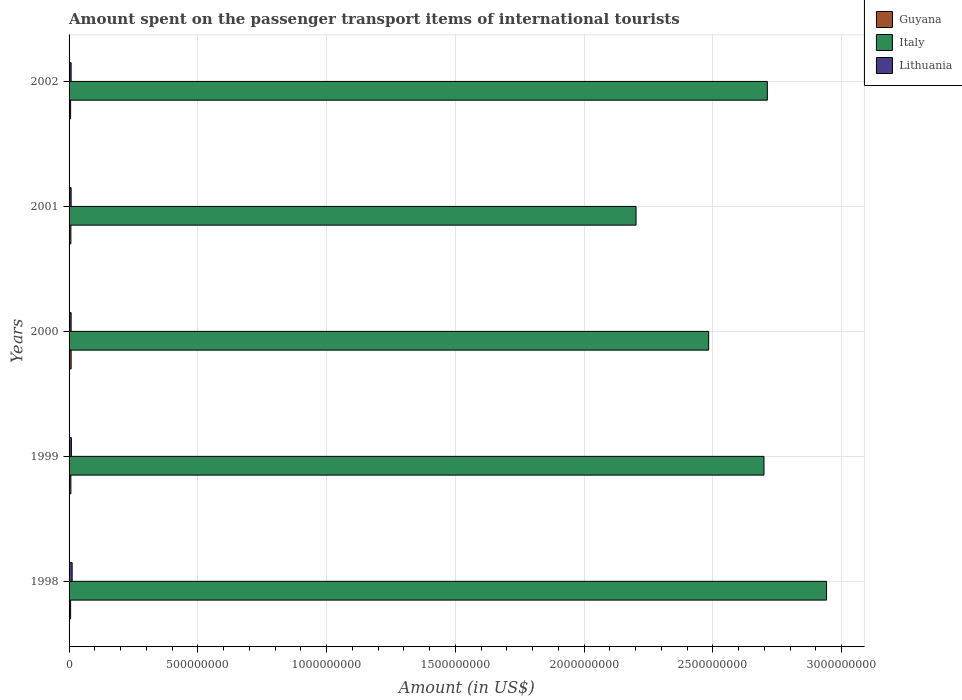How many different coloured bars are there?
Keep it short and to the point. 3. Are the number of bars per tick equal to the number of legend labels?
Your response must be concise. Yes. How many bars are there on the 3rd tick from the bottom?
Make the answer very short. 3. In how many cases, is the number of bars for a given year not equal to the number of legend labels?
Keep it short and to the point. 0. What is the amount spent on the passenger transport items of international tourists in Italy in 1999?
Provide a succinct answer. 2.70e+09. Across all years, what is the maximum amount spent on the passenger transport items of international tourists in Lithuania?
Provide a short and direct response. 1.20e+07. Across all years, what is the minimum amount spent on the passenger transport items of international tourists in Italy?
Provide a succinct answer. 2.20e+09. In which year was the amount spent on the passenger transport items of international tourists in Guyana maximum?
Provide a short and direct response. 2000. In which year was the amount spent on the passenger transport items of international tourists in Guyana minimum?
Ensure brevity in your answer.  1998. What is the total amount spent on the passenger transport items of international tourists in Lithuania in the graph?
Ensure brevity in your answer.  4.50e+07. What is the difference between the amount spent on the passenger transport items of international tourists in Lithuania in 1999 and that in 2002?
Make the answer very short. 1.00e+06. What is the average amount spent on the passenger transport items of international tourists in Italy per year?
Ensure brevity in your answer.  2.61e+09. In the year 1998, what is the difference between the amount spent on the passenger transport items of international tourists in Italy and amount spent on the passenger transport items of international tourists in Lithuania?
Keep it short and to the point. 2.93e+09. Is the amount spent on the passenger transport items of international tourists in Lithuania in 1998 less than that in 1999?
Your response must be concise. No. What is the difference between the highest and the second highest amount spent on the passenger transport items of international tourists in Italy?
Your answer should be very brief. 2.30e+08. What is the difference between the highest and the lowest amount spent on the passenger transport items of international tourists in Italy?
Your response must be concise. 7.40e+08. Is the sum of the amount spent on the passenger transport items of international tourists in Lithuania in 1998 and 2000 greater than the maximum amount spent on the passenger transport items of international tourists in Italy across all years?
Make the answer very short. No. What does the 2nd bar from the bottom in 2001 represents?
Your answer should be very brief. Italy. Is it the case that in every year, the sum of the amount spent on the passenger transport items of international tourists in Italy and amount spent on the passenger transport items of international tourists in Lithuania is greater than the amount spent on the passenger transport items of international tourists in Guyana?
Your answer should be very brief. Yes. Are all the bars in the graph horizontal?
Give a very brief answer. Yes. How many years are there in the graph?
Provide a succinct answer. 5. What is the difference between two consecutive major ticks on the X-axis?
Provide a short and direct response. 5.00e+08. Are the values on the major ticks of X-axis written in scientific E-notation?
Offer a very short reply. No. Does the graph contain any zero values?
Provide a succinct answer. No. How many legend labels are there?
Ensure brevity in your answer.  3. How are the legend labels stacked?
Give a very brief answer. Vertical. What is the title of the graph?
Make the answer very short. Amount spent on the passenger transport items of international tourists. Does "Peru" appear as one of the legend labels in the graph?
Your answer should be very brief. No. What is the label or title of the Y-axis?
Provide a short and direct response. Years. What is the Amount (in US$) in Guyana in 1998?
Provide a short and direct response. 6.00e+06. What is the Amount (in US$) in Italy in 1998?
Offer a terse response. 2.94e+09. What is the Amount (in US$) of Lithuania in 1998?
Offer a terse response. 1.20e+07. What is the Amount (in US$) of Guyana in 1999?
Give a very brief answer. 7.00e+06. What is the Amount (in US$) of Italy in 1999?
Your response must be concise. 2.70e+09. What is the Amount (in US$) of Lithuania in 1999?
Offer a terse response. 9.00e+06. What is the Amount (in US$) in Italy in 2000?
Make the answer very short. 2.48e+09. What is the Amount (in US$) of Guyana in 2001?
Offer a very short reply. 7.00e+06. What is the Amount (in US$) of Italy in 2001?
Your answer should be very brief. 2.20e+09. What is the Amount (in US$) of Italy in 2002?
Your response must be concise. 2.71e+09. Across all years, what is the maximum Amount (in US$) of Guyana?
Keep it short and to the point. 8.00e+06. Across all years, what is the maximum Amount (in US$) in Italy?
Your response must be concise. 2.94e+09. Across all years, what is the maximum Amount (in US$) in Lithuania?
Give a very brief answer. 1.20e+07. Across all years, what is the minimum Amount (in US$) of Italy?
Ensure brevity in your answer.  2.20e+09. Across all years, what is the minimum Amount (in US$) in Lithuania?
Offer a very short reply. 8.00e+06. What is the total Amount (in US$) of Guyana in the graph?
Provide a short and direct response. 3.40e+07. What is the total Amount (in US$) in Italy in the graph?
Provide a short and direct response. 1.30e+1. What is the total Amount (in US$) in Lithuania in the graph?
Make the answer very short. 4.50e+07. What is the difference between the Amount (in US$) of Guyana in 1998 and that in 1999?
Your answer should be very brief. -1.00e+06. What is the difference between the Amount (in US$) in Italy in 1998 and that in 1999?
Offer a terse response. 2.43e+08. What is the difference between the Amount (in US$) of Lithuania in 1998 and that in 1999?
Keep it short and to the point. 3.00e+06. What is the difference between the Amount (in US$) in Guyana in 1998 and that in 2000?
Provide a succinct answer. -2.00e+06. What is the difference between the Amount (in US$) in Italy in 1998 and that in 2000?
Keep it short and to the point. 4.58e+08. What is the difference between the Amount (in US$) of Lithuania in 1998 and that in 2000?
Provide a short and direct response. 4.00e+06. What is the difference between the Amount (in US$) in Guyana in 1998 and that in 2001?
Provide a short and direct response. -1.00e+06. What is the difference between the Amount (in US$) of Italy in 1998 and that in 2001?
Make the answer very short. 7.40e+08. What is the difference between the Amount (in US$) in Lithuania in 1998 and that in 2001?
Offer a terse response. 4.00e+06. What is the difference between the Amount (in US$) of Guyana in 1998 and that in 2002?
Keep it short and to the point. 0. What is the difference between the Amount (in US$) of Italy in 1998 and that in 2002?
Offer a very short reply. 2.30e+08. What is the difference between the Amount (in US$) in Italy in 1999 and that in 2000?
Provide a succinct answer. 2.15e+08. What is the difference between the Amount (in US$) of Guyana in 1999 and that in 2001?
Your answer should be compact. 0. What is the difference between the Amount (in US$) in Italy in 1999 and that in 2001?
Your answer should be very brief. 4.97e+08. What is the difference between the Amount (in US$) of Lithuania in 1999 and that in 2001?
Your response must be concise. 1.00e+06. What is the difference between the Amount (in US$) in Guyana in 1999 and that in 2002?
Your answer should be very brief. 1.00e+06. What is the difference between the Amount (in US$) of Italy in 1999 and that in 2002?
Give a very brief answer. -1.30e+07. What is the difference between the Amount (in US$) in Lithuania in 1999 and that in 2002?
Give a very brief answer. 1.00e+06. What is the difference between the Amount (in US$) of Guyana in 2000 and that in 2001?
Give a very brief answer. 1.00e+06. What is the difference between the Amount (in US$) in Italy in 2000 and that in 2001?
Ensure brevity in your answer.  2.82e+08. What is the difference between the Amount (in US$) in Guyana in 2000 and that in 2002?
Your answer should be very brief. 2.00e+06. What is the difference between the Amount (in US$) of Italy in 2000 and that in 2002?
Your answer should be compact. -2.28e+08. What is the difference between the Amount (in US$) in Lithuania in 2000 and that in 2002?
Your response must be concise. 0. What is the difference between the Amount (in US$) of Italy in 2001 and that in 2002?
Offer a terse response. -5.10e+08. What is the difference between the Amount (in US$) in Lithuania in 2001 and that in 2002?
Make the answer very short. 0. What is the difference between the Amount (in US$) of Guyana in 1998 and the Amount (in US$) of Italy in 1999?
Offer a very short reply. -2.69e+09. What is the difference between the Amount (in US$) in Guyana in 1998 and the Amount (in US$) in Lithuania in 1999?
Give a very brief answer. -3.00e+06. What is the difference between the Amount (in US$) in Italy in 1998 and the Amount (in US$) in Lithuania in 1999?
Your answer should be compact. 2.93e+09. What is the difference between the Amount (in US$) of Guyana in 1998 and the Amount (in US$) of Italy in 2000?
Your response must be concise. -2.48e+09. What is the difference between the Amount (in US$) of Italy in 1998 and the Amount (in US$) of Lithuania in 2000?
Offer a very short reply. 2.93e+09. What is the difference between the Amount (in US$) of Guyana in 1998 and the Amount (in US$) of Italy in 2001?
Your answer should be compact. -2.20e+09. What is the difference between the Amount (in US$) in Guyana in 1998 and the Amount (in US$) in Lithuania in 2001?
Offer a very short reply. -2.00e+06. What is the difference between the Amount (in US$) in Italy in 1998 and the Amount (in US$) in Lithuania in 2001?
Your answer should be very brief. 2.93e+09. What is the difference between the Amount (in US$) of Guyana in 1998 and the Amount (in US$) of Italy in 2002?
Your answer should be compact. -2.71e+09. What is the difference between the Amount (in US$) of Italy in 1998 and the Amount (in US$) of Lithuania in 2002?
Keep it short and to the point. 2.93e+09. What is the difference between the Amount (in US$) in Guyana in 1999 and the Amount (in US$) in Italy in 2000?
Make the answer very short. -2.48e+09. What is the difference between the Amount (in US$) of Guyana in 1999 and the Amount (in US$) of Lithuania in 2000?
Offer a very short reply. -1.00e+06. What is the difference between the Amount (in US$) in Italy in 1999 and the Amount (in US$) in Lithuania in 2000?
Your response must be concise. 2.69e+09. What is the difference between the Amount (in US$) in Guyana in 1999 and the Amount (in US$) in Italy in 2001?
Your answer should be very brief. -2.20e+09. What is the difference between the Amount (in US$) in Guyana in 1999 and the Amount (in US$) in Lithuania in 2001?
Your answer should be compact. -1.00e+06. What is the difference between the Amount (in US$) of Italy in 1999 and the Amount (in US$) of Lithuania in 2001?
Your response must be concise. 2.69e+09. What is the difference between the Amount (in US$) in Guyana in 1999 and the Amount (in US$) in Italy in 2002?
Offer a terse response. -2.70e+09. What is the difference between the Amount (in US$) in Guyana in 1999 and the Amount (in US$) in Lithuania in 2002?
Make the answer very short. -1.00e+06. What is the difference between the Amount (in US$) of Italy in 1999 and the Amount (in US$) of Lithuania in 2002?
Your answer should be compact. 2.69e+09. What is the difference between the Amount (in US$) of Guyana in 2000 and the Amount (in US$) of Italy in 2001?
Offer a very short reply. -2.19e+09. What is the difference between the Amount (in US$) in Guyana in 2000 and the Amount (in US$) in Lithuania in 2001?
Ensure brevity in your answer.  0. What is the difference between the Amount (in US$) of Italy in 2000 and the Amount (in US$) of Lithuania in 2001?
Provide a short and direct response. 2.48e+09. What is the difference between the Amount (in US$) of Guyana in 2000 and the Amount (in US$) of Italy in 2002?
Your response must be concise. -2.70e+09. What is the difference between the Amount (in US$) in Guyana in 2000 and the Amount (in US$) in Lithuania in 2002?
Ensure brevity in your answer.  0. What is the difference between the Amount (in US$) in Italy in 2000 and the Amount (in US$) in Lithuania in 2002?
Give a very brief answer. 2.48e+09. What is the difference between the Amount (in US$) of Guyana in 2001 and the Amount (in US$) of Italy in 2002?
Your response must be concise. -2.70e+09. What is the difference between the Amount (in US$) in Guyana in 2001 and the Amount (in US$) in Lithuania in 2002?
Keep it short and to the point. -1.00e+06. What is the difference between the Amount (in US$) of Italy in 2001 and the Amount (in US$) of Lithuania in 2002?
Your response must be concise. 2.19e+09. What is the average Amount (in US$) of Guyana per year?
Provide a short and direct response. 6.80e+06. What is the average Amount (in US$) in Italy per year?
Provide a succinct answer. 2.61e+09. What is the average Amount (in US$) in Lithuania per year?
Ensure brevity in your answer.  9.00e+06. In the year 1998, what is the difference between the Amount (in US$) of Guyana and Amount (in US$) of Italy?
Provide a succinct answer. -2.94e+09. In the year 1998, what is the difference between the Amount (in US$) in Guyana and Amount (in US$) in Lithuania?
Give a very brief answer. -6.00e+06. In the year 1998, what is the difference between the Amount (in US$) of Italy and Amount (in US$) of Lithuania?
Keep it short and to the point. 2.93e+09. In the year 1999, what is the difference between the Amount (in US$) of Guyana and Amount (in US$) of Italy?
Ensure brevity in your answer.  -2.69e+09. In the year 1999, what is the difference between the Amount (in US$) of Guyana and Amount (in US$) of Lithuania?
Provide a short and direct response. -2.00e+06. In the year 1999, what is the difference between the Amount (in US$) in Italy and Amount (in US$) in Lithuania?
Your answer should be compact. 2.69e+09. In the year 2000, what is the difference between the Amount (in US$) of Guyana and Amount (in US$) of Italy?
Ensure brevity in your answer.  -2.48e+09. In the year 2000, what is the difference between the Amount (in US$) in Italy and Amount (in US$) in Lithuania?
Offer a terse response. 2.48e+09. In the year 2001, what is the difference between the Amount (in US$) in Guyana and Amount (in US$) in Italy?
Keep it short and to the point. -2.20e+09. In the year 2001, what is the difference between the Amount (in US$) of Italy and Amount (in US$) of Lithuania?
Give a very brief answer. 2.19e+09. In the year 2002, what is the difference between the Amount (in US$) of Guyana and Amount (in US$) of Italy?
Provide a succinct answer. -2.71e+09. In the year 2002, what is the difference between the Amount (in US$) in Guyana and Amount (in US$) in Lithuania?
Ensure brevity in your answer.  -2.00e+06. In the year 2002, what is the difference between the Amount (in US$) in Italy and Amount (in US$) in Lithuania?
Provide a short and direct response. 2.70e+09. What is the ratio of the Amount (in US$) of Italy in 1998 to that in 1999?
Your response must be concise. 1.09. What is the ratio of the Amount (in US$) of Lithuania in 1998 to that in 1999?
Your answer should be compact. 1.33. What is the ratio of the Amount (in US$) in Guyana in 1998 to that in 2000?
Make the answer very short. 0.75. What is the ratio of the Amount (in US$) of Italy in 1998 to that in 2000?
Give a very brief answer. 1.18. What is the ratio of the Amount (in US$) in Lithuania in 1998 to that in 2000?
Your answer should be very brief. 1.5. What is the ratio of the Amount (in US$) in Guyana in 1998 to that in 2001?
Keep it short and to the point. 0.86. What is the ratio of the Amount (in US$) of Italy in 1998 to that in 2001?
Make the answer very short. 1.34. What is the ratio of the Amount (in US$) of Lithuania in 1998 to that in 2001?
Your answer should be very brief. 1.5. What is the ratio of the Amount (in US$) of Guyana in 1998 to that in 2002?
Keep it short and to the point. 1. What is the ratio of the Amount (in US$) in Italy in 1998 to that in 2002?
Your answer should be compact. 1.08. What is the ratio of the Amount (in US$) in Guyana in 1999 to that in 2000?
Offer a very short reply. 0.88. What is the ratio of the Amount (in US$) in Italy in 1999 to that in 2000?
Offer a very short reply. 1.09. What is the ratio of the Amount (in US$) in Lithuania in 1999 to that in 2000?
Your response must be concise. 1.12. What is the ratio of the Amount (in US$) in Italy in 1999 to that in 2001?
Provide a short and direct response. 1.23. What is the ratio of the Amount (in US$) of Guyana in 1999 to that in 2002?
Offer a terse response. 1.17. What is the ratio of the Amount (in US$) of Lithuania in 1999 to that in 2002?
Your answer should be very brief. 1.12. What is the ratio of the Amount (in US$) in Guyana in 2000 to that in 2001?
Keep it short and to the point. 1.14. What is the ratio of the Amount (in US$) of Italy in 2000 to that in 2001?
Make the answer very short. 1.13. What is the ratio of the Amount (in US$) of Guyana in 2000 to that in 2002?
Offer a very short reply. 1.33. What is the ratio of the Amount (in US$) of Italy in 2000 to that in 2002?
Provide a short and direct response. 0.92. What is the ratio of the Amount (in US$) in Guyana in 2001 to that in 2002?
Provide a short and direct response. 1.17. What is the ratio of the Amount (in US$) of Italy in 2001 to that in 2002?
Your answer should be compact. 0.81. What is the difference between the highest and the second highest Amount (in US$) in Italy?
Offer a terse response. 2.30e+08. What is the difference between the highest and the lowest Amount (in US$) in Italy?
Make the answer very short. 7.40e+08. What is the difference between the highest and the lowest Amount (in US$) in Lithuania?
Your answer should be very brief. 4.00e+06. 